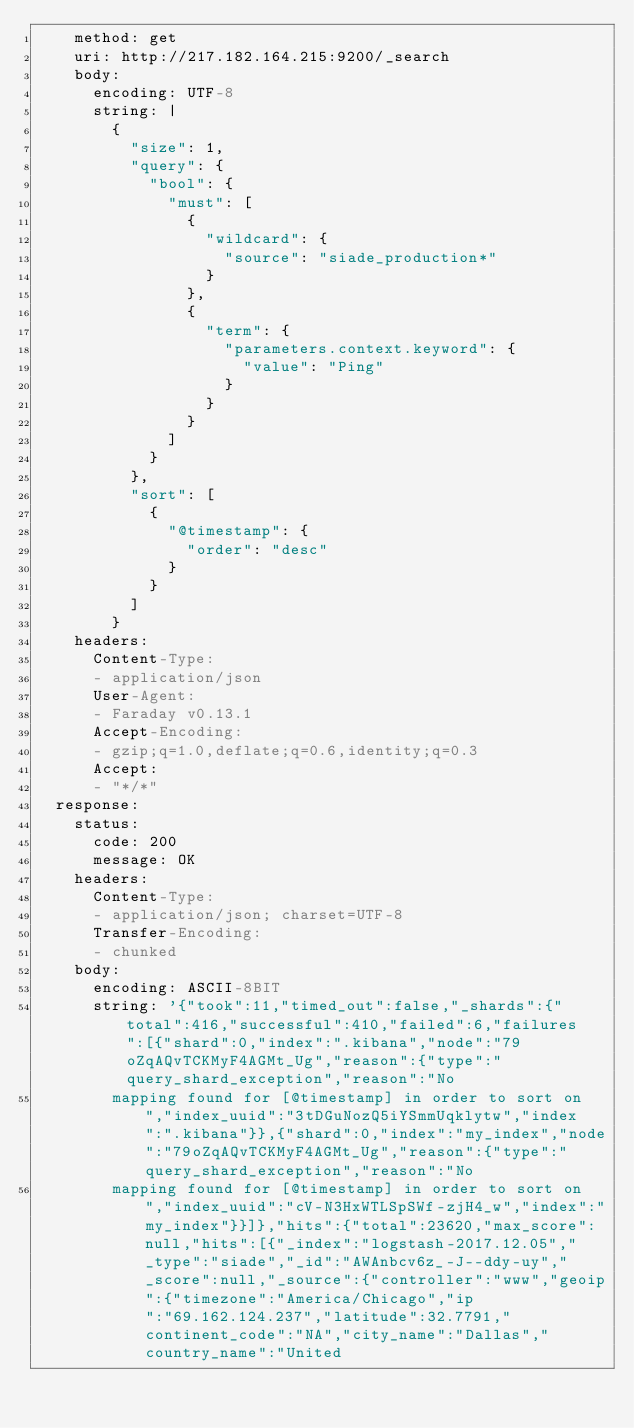<code> <loc_0><loc_0><loc_500><loc_500><_YAML_>    method: get
    uri: http://217.182.164.215:9200/_search
    body:
      encoding: UTF-8
      string: |
        {
          "size": 1,
          "query": {
            "bool": {
              "must": [
                {
                  "wildcard": {
                    "source": "siade_production*"
                  }
                },
                {
                  "term": {
                    "parameters.context.keyword": {
                      "value": "Ping"
                    }
                  }
                }
              ]
            }
          },
          "sort": [
            {
              "@timestamp": {
                "order": "desc"
              }
            }
          ]
        }
    headers:
      Content-Type:
      - application/json
      User-Agent:
      - Faraday v0.13.1
      Accept-Encoding:
      - gzip;q=1.0,deflate;q=0.6,identity;q=0.3
      Accept:
      - "*/*"
  response:
    status:
      code: 200
      message: OK
    headers:
      Content-Type:
      - application/json; charset=UTF-8
      Transfer-Encoding:
      - chunked
    body:
      encoding: ASCII-8BIT
      string: '{"took":11,"timed_out":false,"_shards":{"total":416,"successful":410,"failed":6,"failures":[{"shard":0,"index":".kibana","node":"79oZqAQvTCKMyF4AGMt_Ug","reason":{"type":"query_shard_exception","reason":"No
        mapping found for [@timestamp] in order to sort on","index_uuid":"3tDGuNozQ5iYSmmUqklytw","index":".kibana"}},{"shard":0,"index":"my_index","node":"79oZqAQvTCKMyF4AGMt_Ug","reason":{"type":"query_shard_exception","reason":"No
        mapping found for [@timestamp] in order to sort on","index_uuid":"cV-N3HxWTLSpSWf-zjH4_w","index":"my_index"}}]},"hits":{"total":23620,"max_score":null,"hits":[{"_index":"logstash-2017.12.05","_type":"siade","_id":"AWAnbcv6z_-J--ddy-uy","_score":null,"_source":{"controller":"www","geoip":{"timezone":"America/Chicago","ip":"69.162.124.237","latitude":32.7791,"continent_code":"NA","city_name":"Dallas","country_name":"United</code> 